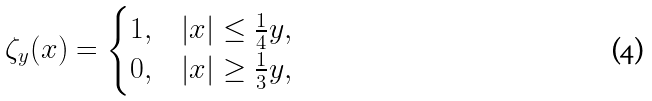Convert formula to latex. <formula><loc_0><loc_0><loc_500><loc_500>\zeta _ { y } ( x ) = \begin{cases} 1 , & | x | \leq \frac { 1 } { 4 } y , \\ 0 , & | x | \geq \frac { 1 } { 3 } y , \end{cases}</formula> 